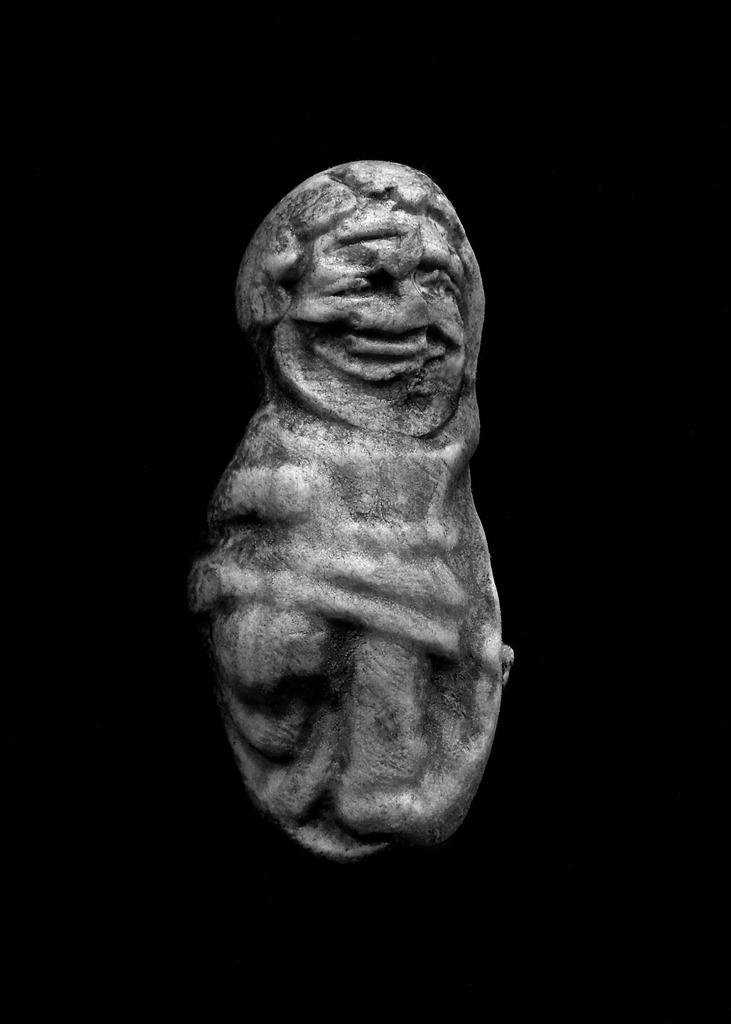What is depicted on the stone in the image? There is carving on a stone in the image. What color is the background of the image? The background of the image is black. What type of slope can be seen in the image? There is no slope present in the image; it features a stone with carving and a black background. How many pieces of lumber are visible in the image? There is no lumber present in the image. 